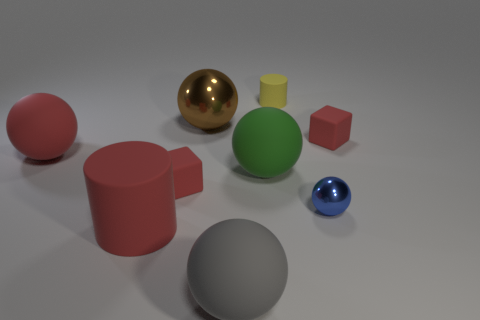The other thing that is the same material as the brown object is what size?
Offer a very short reply. Small. How many large balls are the same color as the large cylinder?
Offer a terse response. 1. Is the number of large balls that are behind the small yellow matte cylinder less than the number of small yellow cylinders right of the blue thing?
Your answer should be compact. No. What size is the shiny ball that is on the left side of the green thing?
Your response must be concise. Large. What is the size of the ball that is the same color as the large rubber cylinder?
Your answer should be compact. Large. Are there any small balls made of the same material as the small yellow cylinder?
Provide a succinct answer. No. Are the blue ball and the brown ball made of the same material?
Provide a succinct answer. Yes. There is a metallic sphere that is the same size as the yellow matte cylinder; what is its color?
Keep it short and to the point. Blue. What number of other objects are there of the same shape as the large gray object?
Your answer should be very brief. 4. There is a gray rubber thing; does it have the same size as the metal thing that is behind the red sphere?
Keep it short and to the point. Yes. 